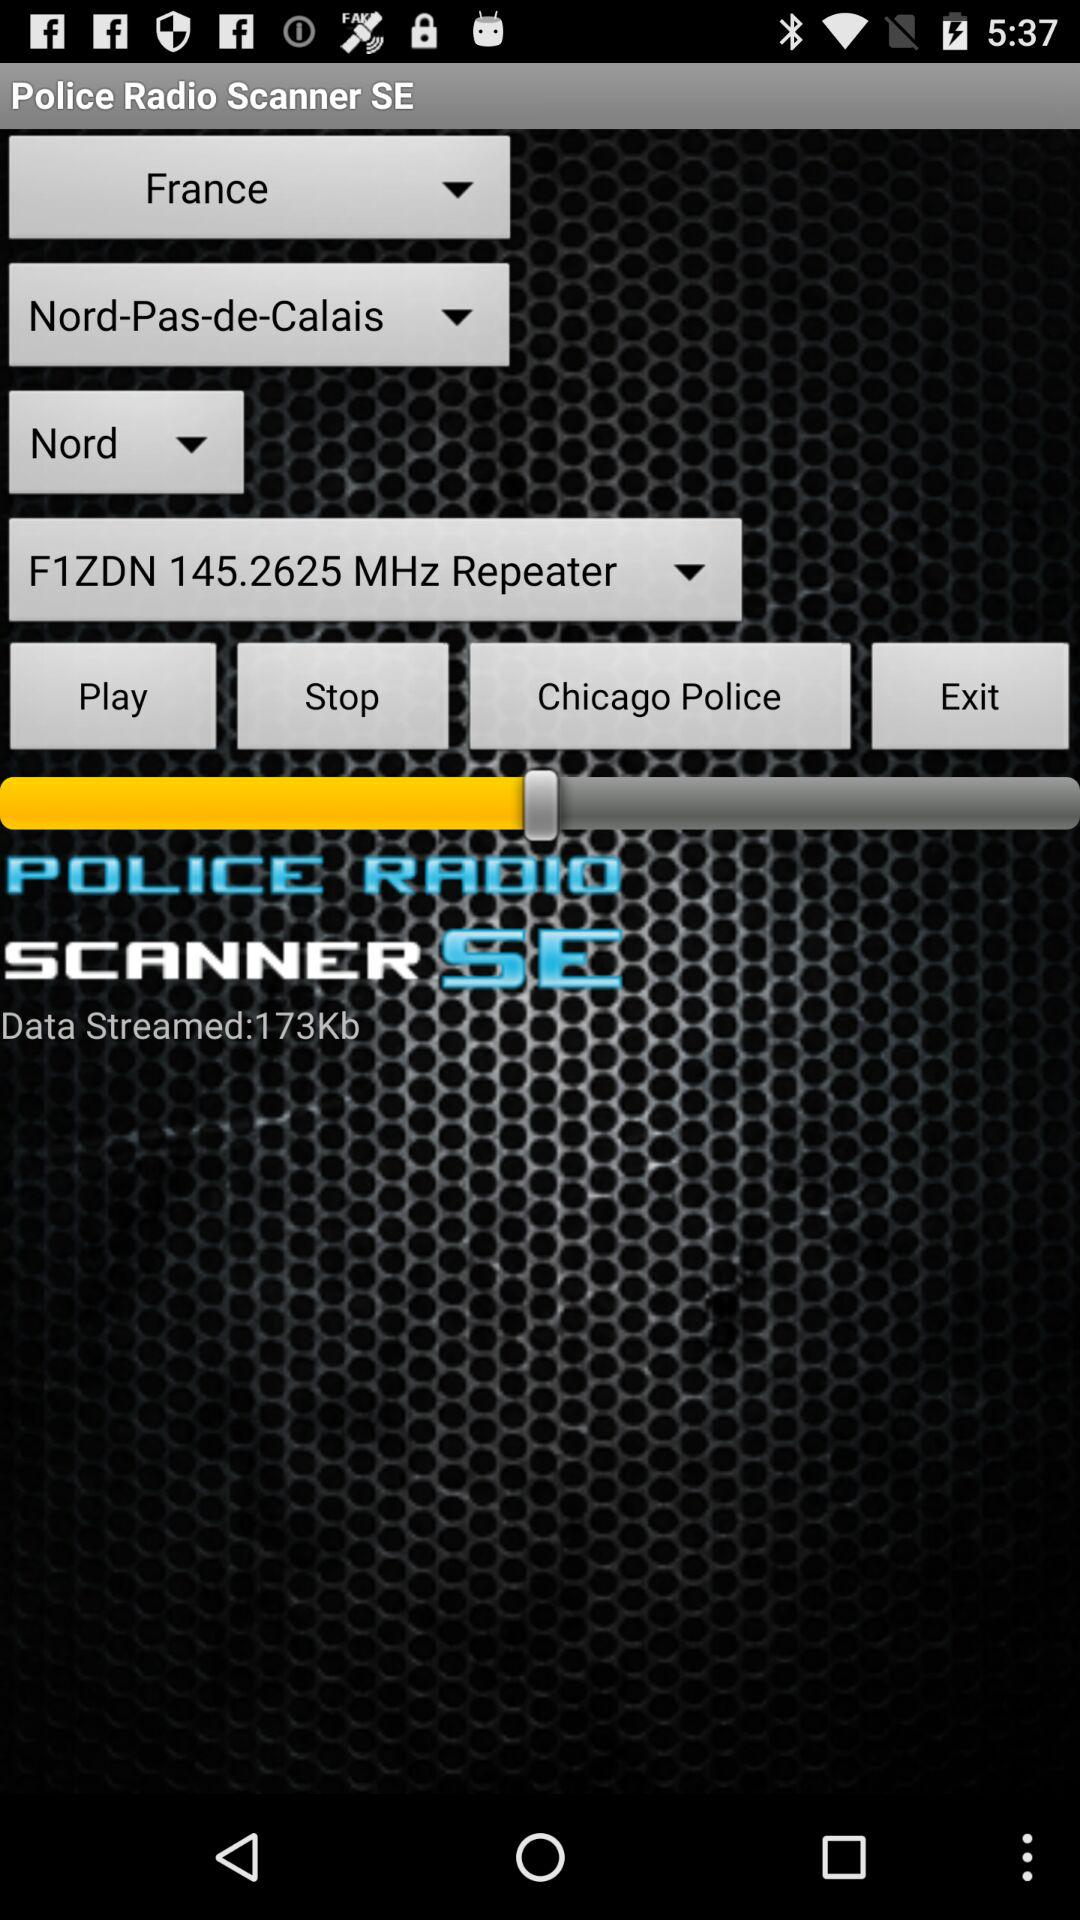What is the frequency? The frequency is 145.2625 MHz. 